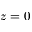Convert formula to latex. <formula><loc_0><loc_0><loc_500><loc_500>z = 0</formula> 